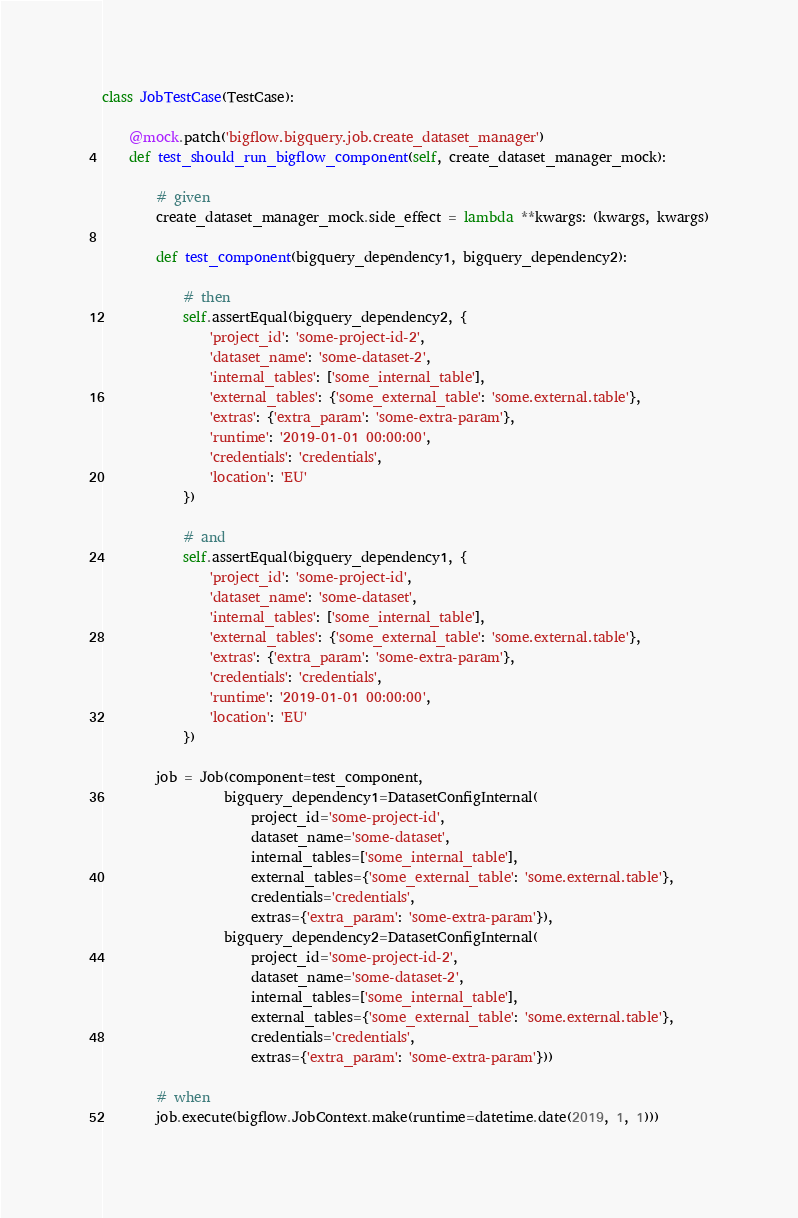Convert code to text. <code><loc_0><loc_0><loc_500><loc_500><_Python_>
class JobTestCase(TestCase):

    @mock.patch('bigflow.bigquery.job.create_dataset_manager')
    def test_should_run_bigflow_component(self, create_dataset_manager_mock):

        # given
        create_dataset_manager_mock.side_effect = lambda **kwargs: (kwargs, kwargs)

        def test_component(bigquery_dependency1, bigquery_dependency2):

            # then
            self.assertEqual(bigquery_dependency2, {
                'project_id': 'some-project-id-2',
                'dataset_name': 'some-dataset-2',
                'internal_tables': ['some_internal_table'],
                'external_tables': {'some_external_table': 'some.external.table'},
                'extras': {'extra_param': 'some-extra-param'},
                'runtime': '2019-01-01 00:00:00',
                'credentials': 'credentials',
                'location': 'EU'
            })

            # and
            self.assertEqual(bigquery_dependency1, {
                'project_id': 'some-project-id',
                'dataset_name': 'some-dataset',
                'internal_tables': ['some_internal_table'],
                'external_tables': {'some_external_table': 'some.external.table'},
                'extras': {'extra_param': 'some-extra-param'},
                'credentials': 'credentials',
                'runtime': '2019-01-01 00:00:00',
                'location': 'EU'
            })

        job = Job(component=test_component,
                  bigquery_dependency1=DatasetConfigInternal(
                      project_id='some-project-id',
                      dataset_name='some-dataset',
                      internal_tables=['some_internal_table'],
                      external_tables={'some_external_table': 'some.external.table'},
                      credentials='credentials',
                      extras={'extra_param': 'some-extra-param'}),
                  bigquery_dependency2=DatasetConfigInternal(
                      project_id='some-project-id-2',
                      dataset_name='some-dataset-2',
                      internal_tables=['some_internal_table'],
                      external_tables={'some_external_table': 'some.external.table'},
                      credentials='credentials',
                      extras={'extra_param': 'some-extra-param'}))

        # when
        job.execute(bigflow.JobContext.make(runtime=datetime.date(2019, 1, 1)))</code> 